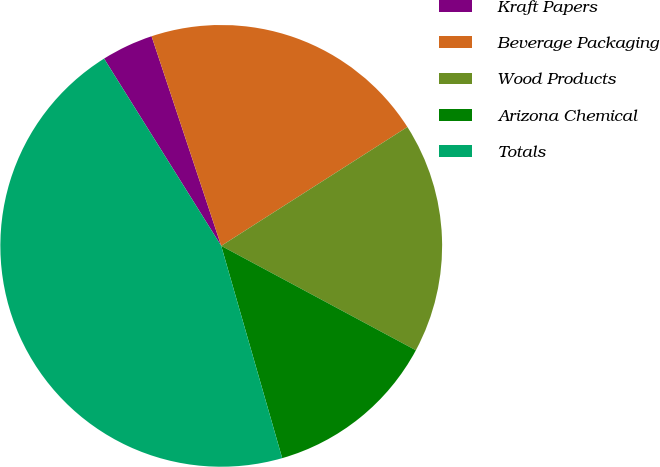Convert chart to OTSL. <chart><loc_0><loc_0><loc_500><loc_500><pie_chart><fcel>Kraft Papers<fcel>Beverage Packaging<fcel>Wood Products<fcel>Arizona Chemical<fcel>Totals<nl><fcel>3.79%<fcel>21.06%<fcel>16.88%<fcel>12.71%<fcel>45.55%<nl></chart> 